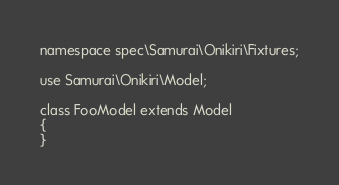Convert code to text. <code><loc_0><loc_0><loc_500><loc_500><_PHP_>namespace spec\Samurai\Onikiri\Fixtures;

use Samurai\Onikiri\Model;

class FooModel extends Model
{
}

</code> 